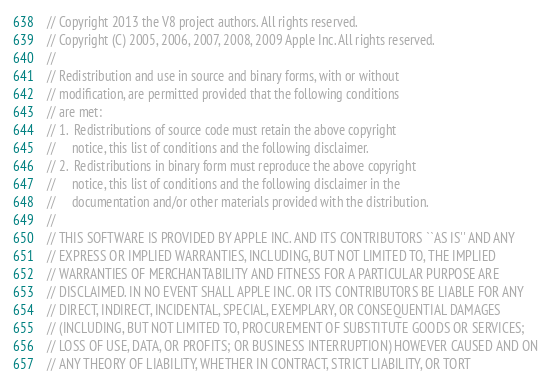<code> <loc_0><loc_0><loc_500><loc_500><_JavaScript_>// Copyright 2013 the V8 project authors. All rights reserved.
// Copyright (C) 2005, 2006, 2007, 2008, 2009 Apple Inc. All rights reserved.
//
// Redistribution and use in source and binary forms, with or without
// modification, are permitted provided that the following conditions
// are met:
// 1.  Redistributions of source code must retain the above copyright
//     notice, this list of conditions and the following disclaimer.
// 2.  Redistributions in binary form must reproduce the above copyright
//     notice, this list of conditions and the following disclaimer in the
//     documentation and/or other materials provided with the distribution.
//
// THIS SOFTWARE IS PROVIDED BY APPLE INC. AND ITS CONTRIBUTORS ``AS IS'' AND ANY
// EXPRESS OR IMPLIED WARRANTIES, INCLUDING, BUT NOT LIMITED TO, THE IMPLIED
// WARRANTIES OF MERCHANTABILITY AND FITNESS FOR A PARTICULAR PURPOSE ARE
// DISCLAIMED. IN NO EVENT SHALL APPLE INC. OR ITS CONTRIBUTORS BE LIABLE FOR ANY
// DIRECT, INDIRECT, INCIDENTAL, SPECIAL, EXEMPLARY, OR CONSEQUENTIAL DAMAGES
// (INCLUDING, BUT NOT LIMITED TO, PROCUREMENT OF SUBSTITUTE GOODS OR SERVICES;
// LOSS OF USE, DATA, OR PROFITS; OR BUSINESS INTERRUPTION) HOWEVER CAUSED AND ON
// ANY THEORY OF LIABILITY, WHETHER IN CONTRACT, STRICT LIABILITY, OR TORT</code> 